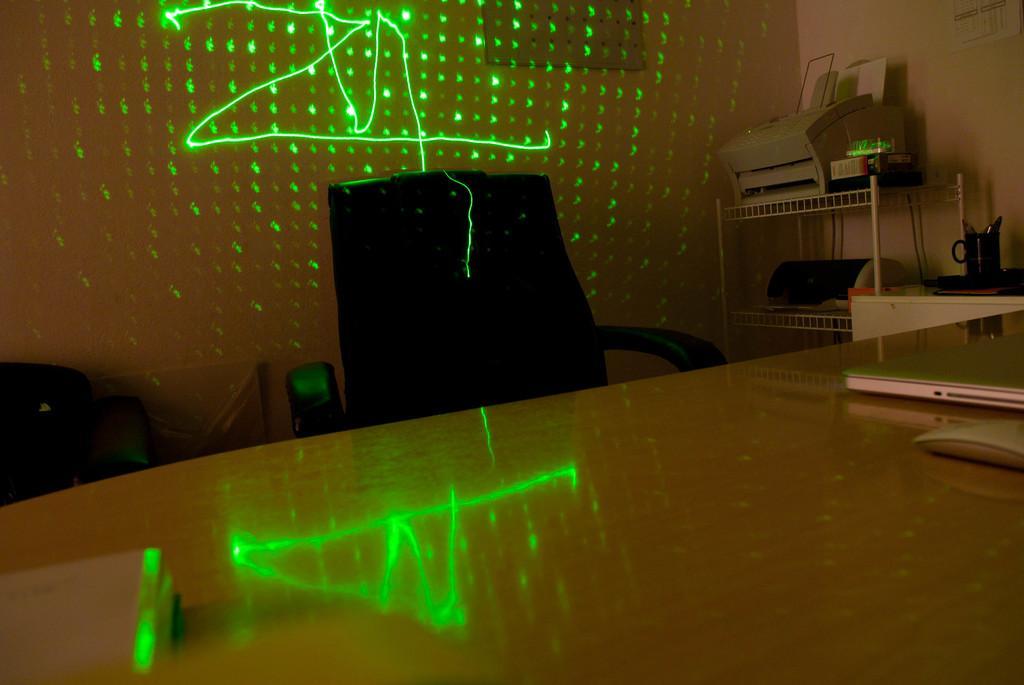In one or two sentences, can you explain what this image depicts? In this picture, there is a table at the bottom. Towards the right, on the table, there is a laptop and a mouse. Beside it, there is a chair. At the top right, there is a rack with a printer and another device. Beside it, there is a desk. On the desk, there is a cup. To the wall, there are lights. 